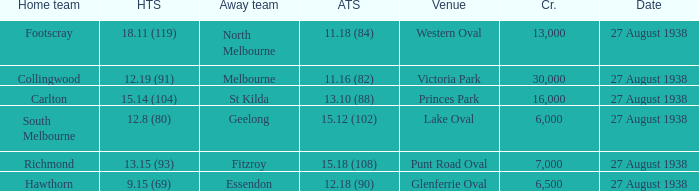Which Team plays at Western Oval? Footscray. 